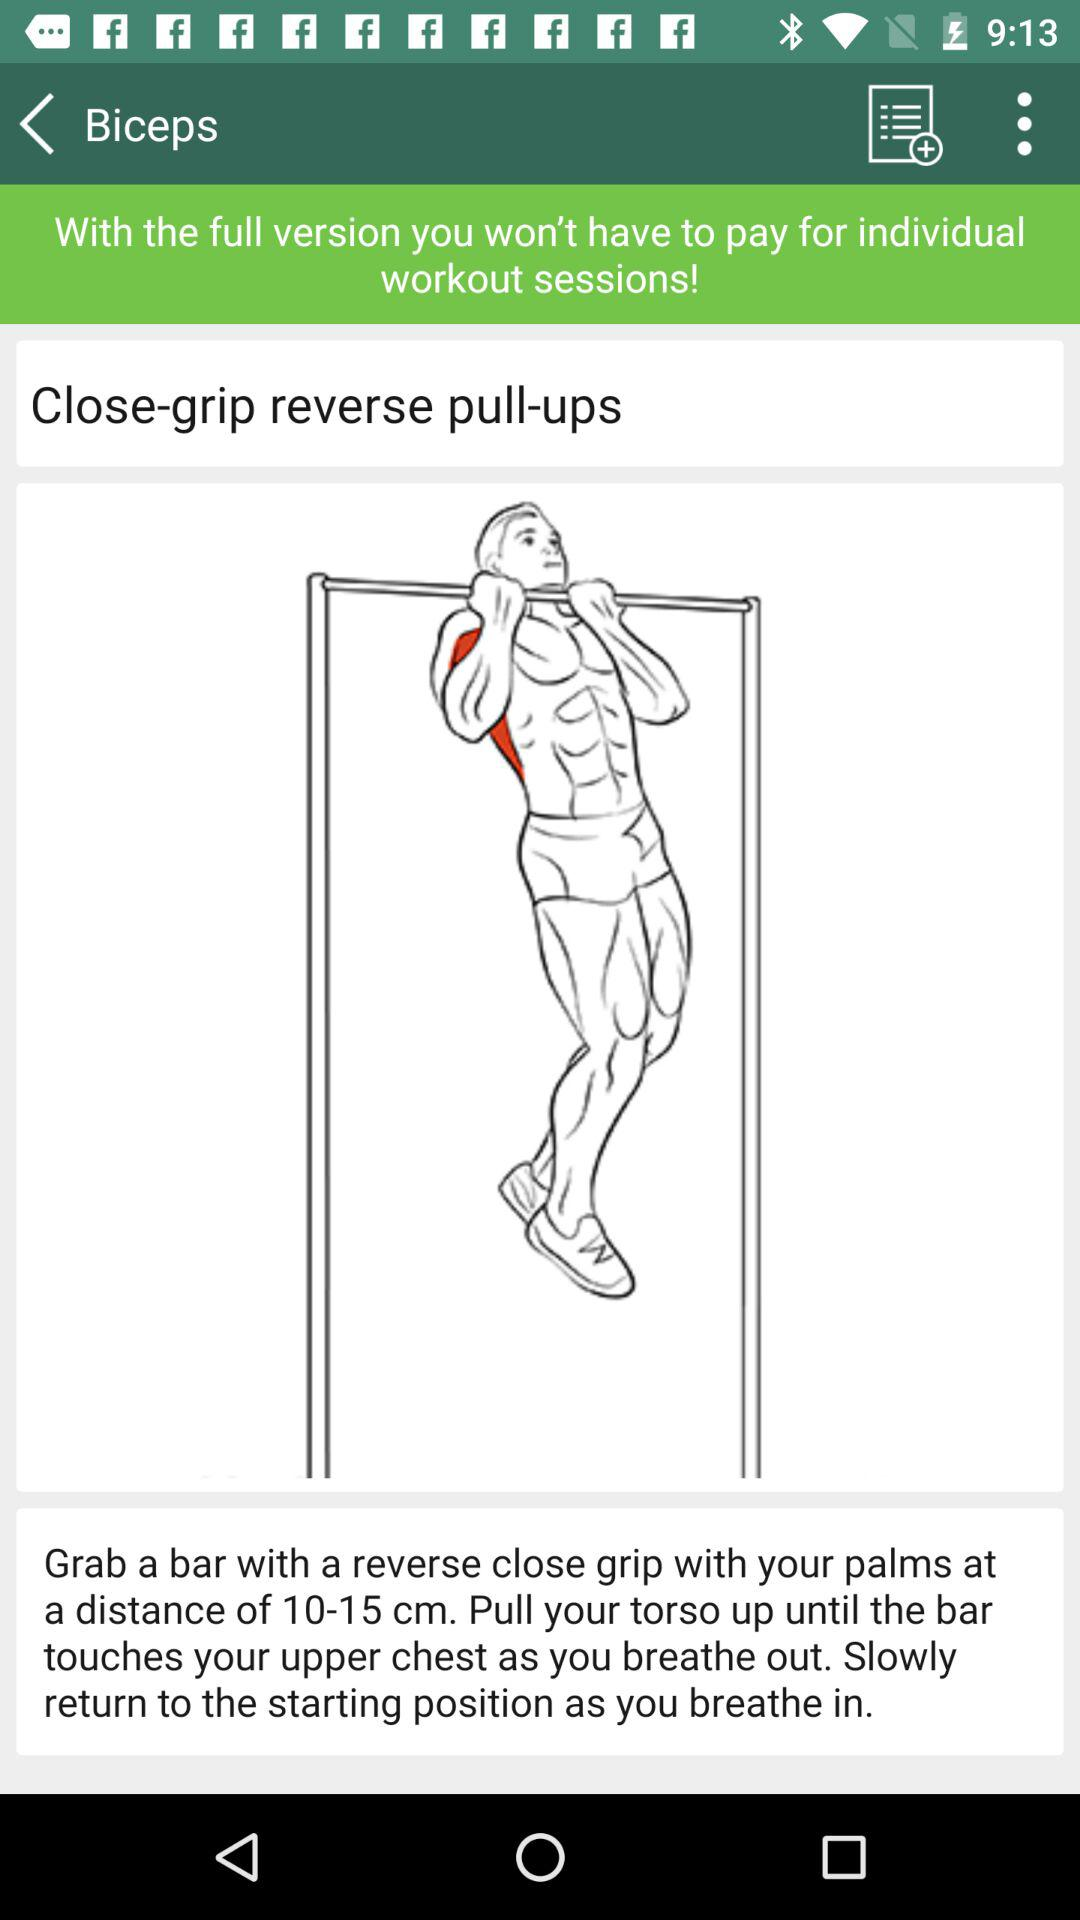Which exercises work the triceps?
When the provided information is insufficient, respond with <no answer>. <no answer> 